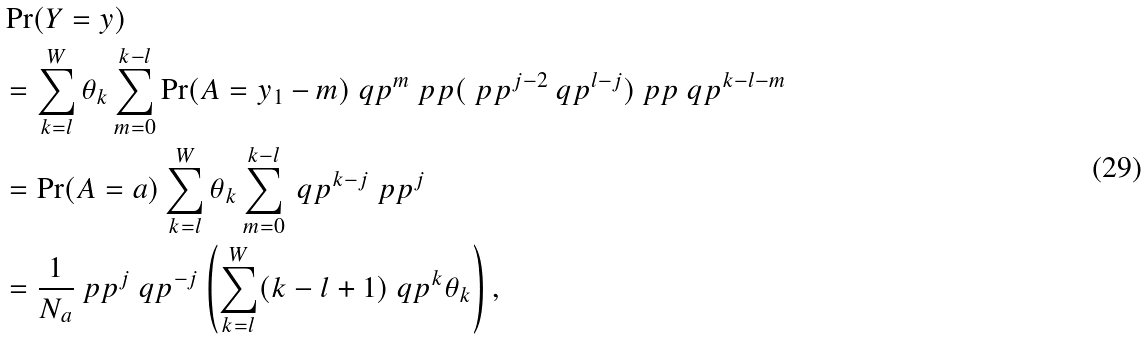Convert formula to latex. <formula><loc_0><loc_0><loc_500><loc_500>& \Pr ( Y = y ) \\ & = \sum _ { k = l } ^ { W } \theta _ { k } \sum _ { m = 0 } ^ { k - l } \Pr ( A = y _ { 1 } - m ) \ q p ^ { m } \ p p ( \ p p ^ { j - 2 } \ q p ^ { l - j } ) \ p p \ q p ^ { k - l - m } \\ & = \Pr ( A = a ) \sum ^ { W } _ { k = l } \theta _ { k } \sum ^ { k - l } _ { m = 0 } \ q p ^ { k - j } \ p p ^ { j } \\ & = \frac { 1 } { N _ { a } } \ p p ^ { j } \ q p ^ { - j } \left ( \sum ^ { W } _ { k = l } ( k - l + 1 ) \ q p ^ { k } \theta _ { k } \right ) ,</formula> 